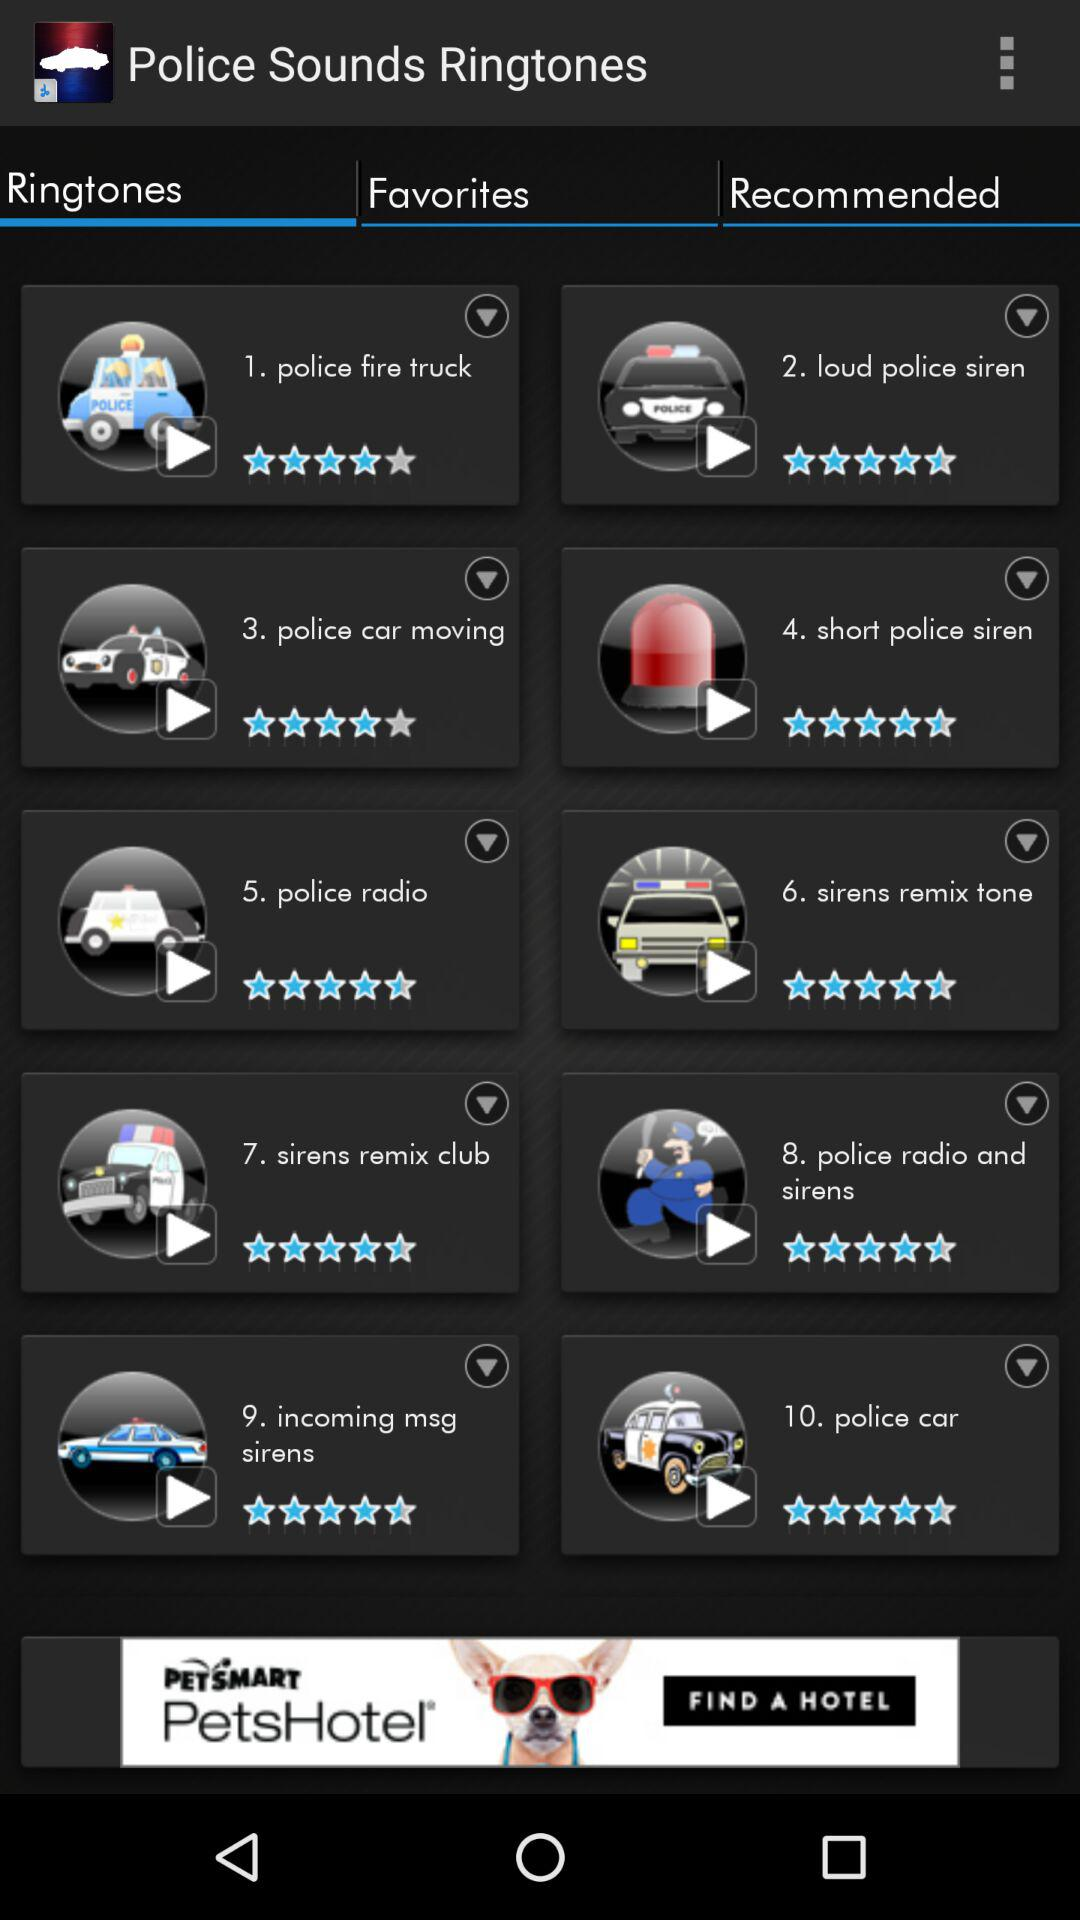What is the rating of the "police car" ringtone? The rating of the "police car" ringtone is 4.5 stars. 